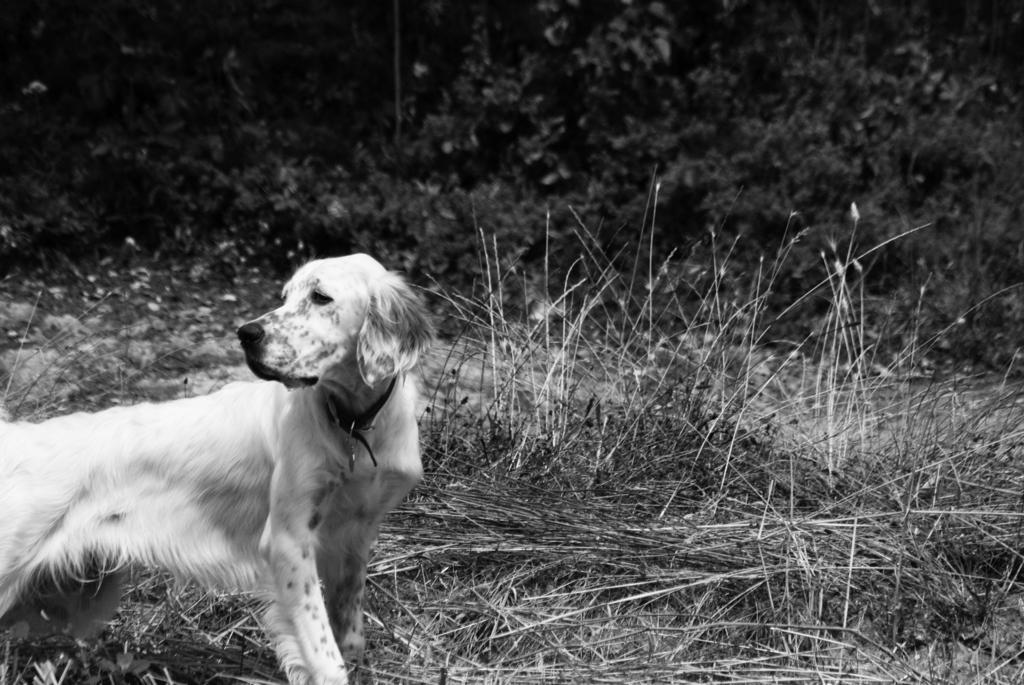Please provide a concise description of this image. In the picture I can see a dog is standing on the ground. In the background I can see plants and grass. This picture is black and white in color. 